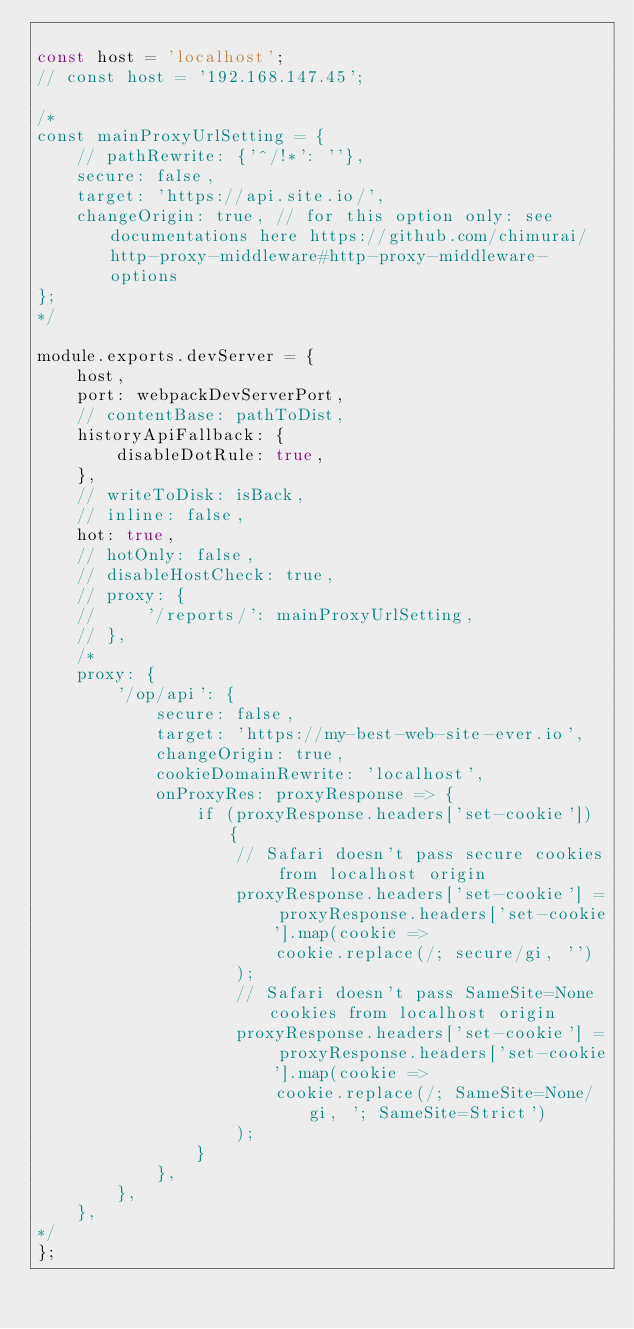Convert code to text. <code><loc_0><loc_0><loc_500><loc_500><_JavaScript_>
const host = 'localhost';
// const host = '192.168.147.45';

/*
const mainProxyUrlSetting = {
    // pathRewrite: {'^/!*': ''},
    secure: false,
    target: 'https://api.site.io/',
    changeOrigin: true, // for this option only: see documentations here https://github.com/chimurai/http-proxy-middleware#http-proxy-middleware-options
};
*/

module.exports.devServer = {
    host,
    port: webpackDevServerPort,
    // contentBase: pathToDist,
    historyApiFallback: {
        disableDotRule: true,
    },
    // writeToDisk: isBack,
    // inline: false,
    hot: true,
    // hotOnly: false,
    // disableHostCheck: true,
    // proxy: {
    //     '/reports/': mainProxyUrlSetting,
    // },
    /*
    proxy: {
        '/op/api': {
            secure: false,
            target: 'https://my-best-web-site-ever.io',
            changeOrigin: true,
            cookieDomainRewrite: 'localhost',
            onProxyRes: proxyResponse => {
                if (proxyResponse.headers['set-cookie']) {
                    // Safari doesn't pass secure cookies from localhost origin
                    proxyResponse.headers['set-cookie'] = proxyResponse.headers['set-cookie'].map(cookie =>
                        cookie.replace(/; secure/gi, '')
                    );
                    // Safari doesn't pass SameSite=None cookies from localhost origin
                    proxyResponse.headers['set-cookie'] = proxyResponse.headers['set-cookie'].map(cookie =>
                        cookie.replace(/; SameSite=None/gi, '; SameSite=Strict')
                    );
                }
            },
        },
    },
*/
};
</code> 